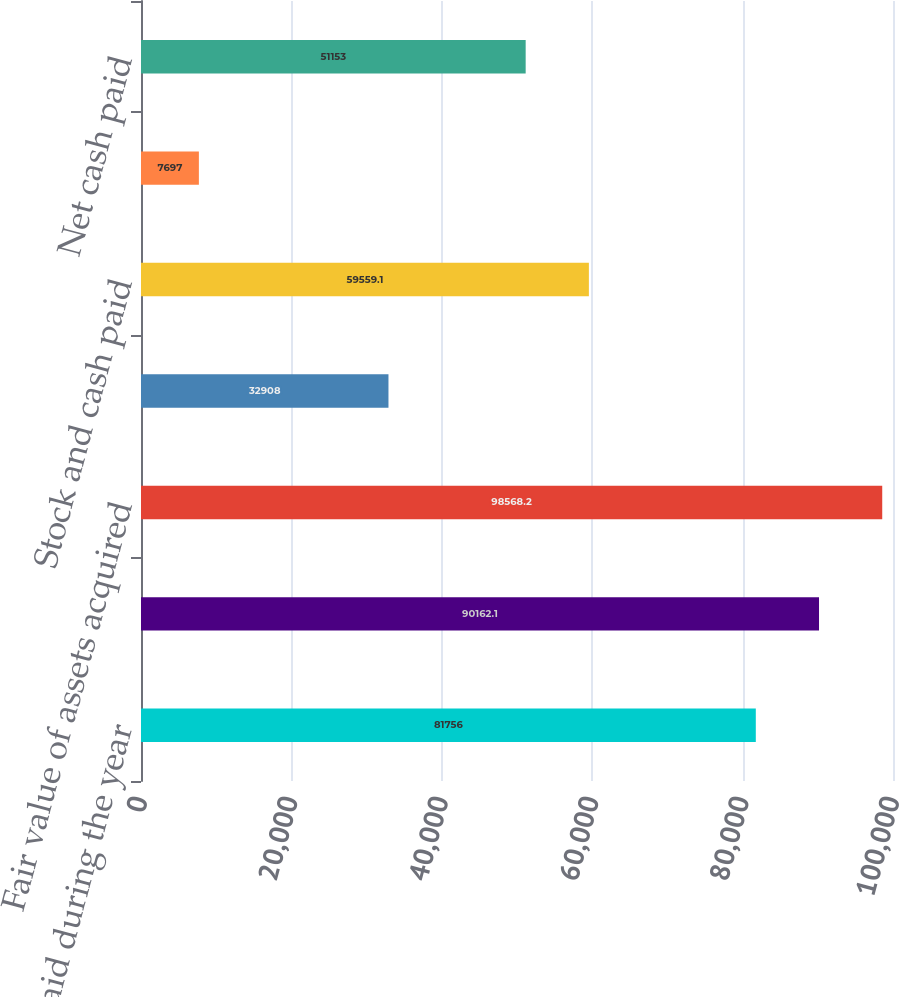<chart> <loc_0><loc_0><loc_500><loc_500><bar_chart><fcel>Interest paid during the year<fcel>Income taxes paid during the<fcel>Fair value of assets acquired<fcel>Liabilities assumed<fcel>Stock and cash paid<fcel>Less Cash acquired<fcel>Net cash paid<nl><fcel>81756<fcel>90162.1<fcel>98568.2<fcel>32908<fcel>59559.1<fcel>7697<fcel>51153<nl></chart> 